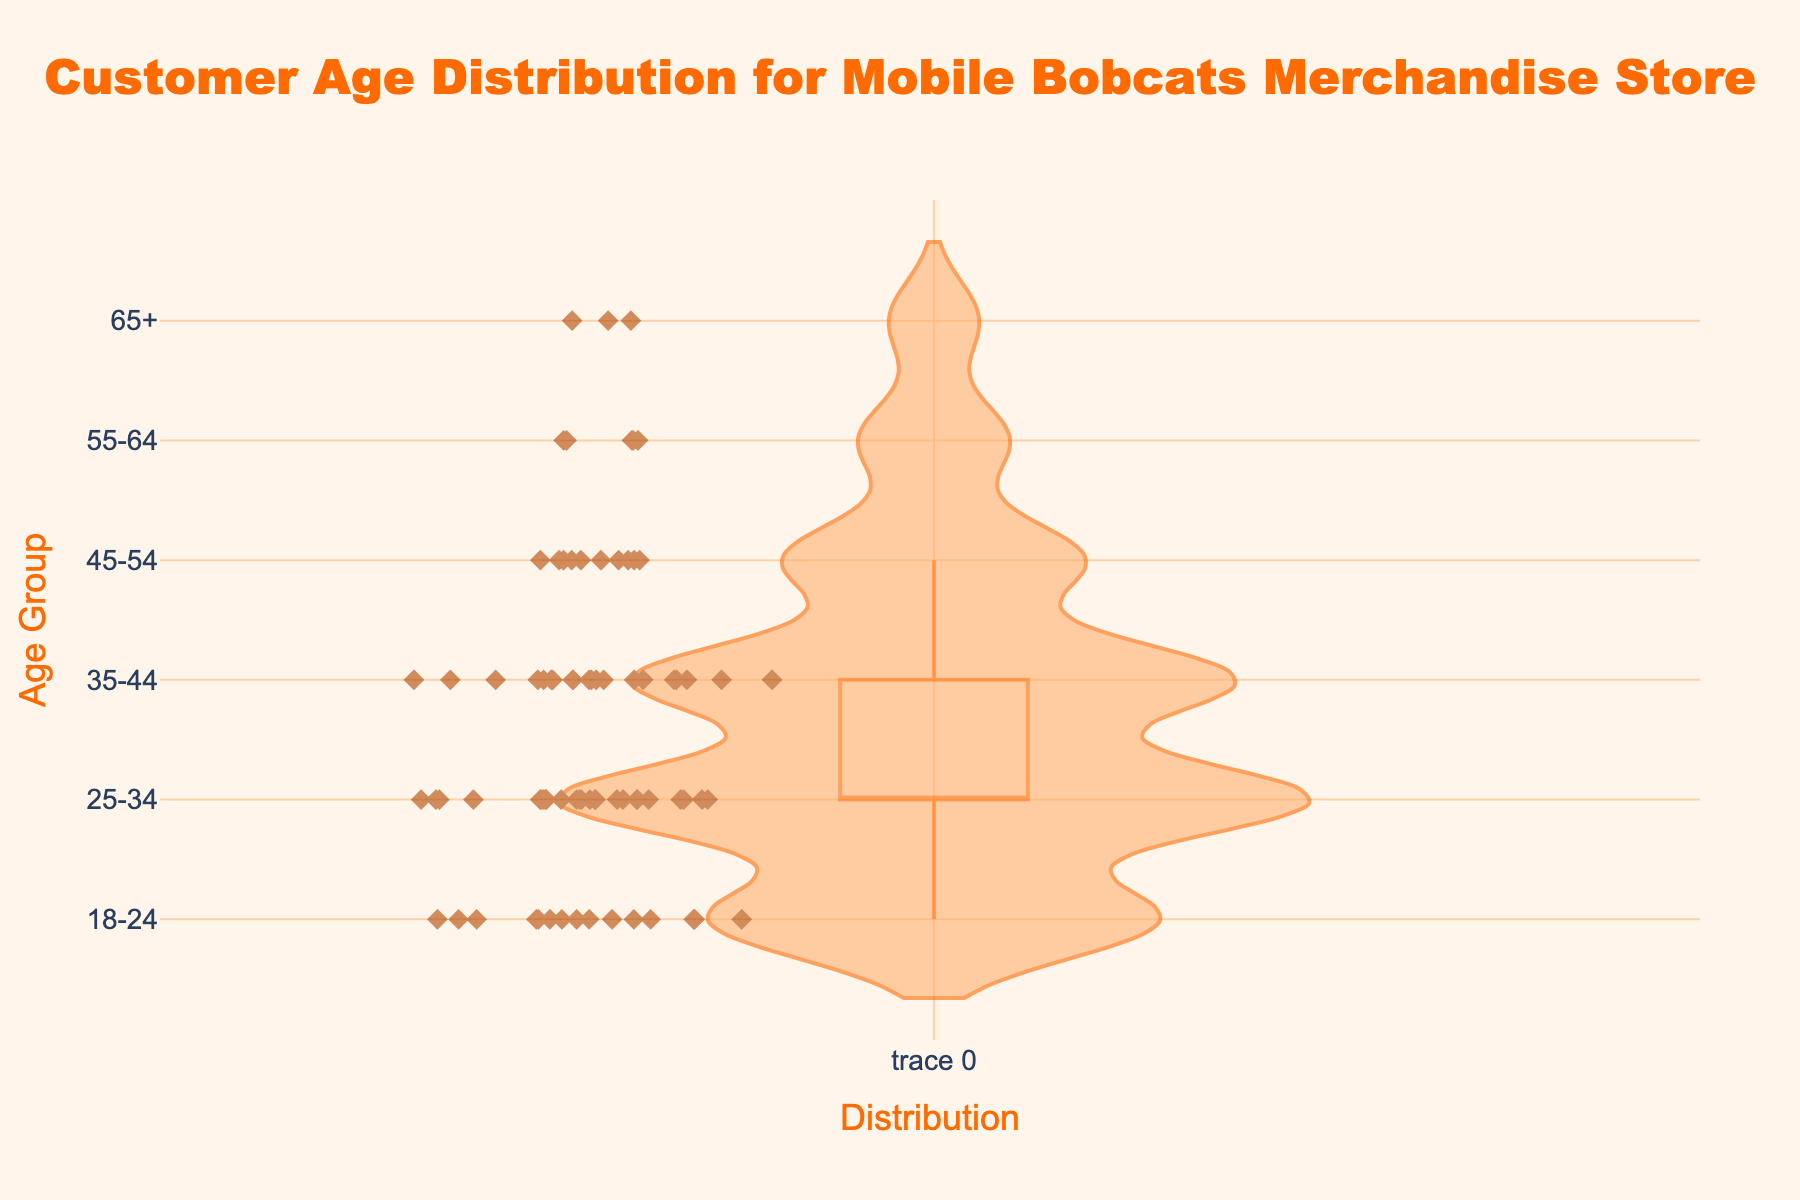What is the title of the figure? The title of the figure is often placed at the top and is typically larger and more prominent. In this figure, it is clearly stated: "Customer Age Distribution for Mobile Bobcats Merchandise Store".
Answer: Customer Age Distribution for Mobile Bobcats Merchandise Store What do the colors represent in the violin plot? In this violin plot, the colors are used for visual aesthetics and to distinguish various components. The fill color of the plot is an orange shade, which visually separates the density area. The markers (points) are brown and represent individual data points with a diamond shape to highlight them.
Answer: Different parts of the plot Which age group has the highest customer count? By looking at the distribution of points along the y-axis and their concentration, the age group '25-34' appears to have the most points. Checking the distribution confirms this visually.
Answer: 25-34 How many customer data points fall in the age group 55-64? The plot shows individual diamond markers for each data point. For '55-64', we see exactly five markers corresponding to the count.
Answer: 5 What is the visible range of age groups on the y-axis? The y-axis shows the divisions for each age group. From the plot, we see age groups starting from '18-24' to '65+'.
Answer: 18-24 to 65+ Which age group has the least number of customers? By counting the points in each age group and comparing them, the '65+' age group has the fewest points.
Answer: 65+ Compare the customer counts between the age groups 35-44 and 45-54. The number of points for '35-44' and '45-54' can be counted to compare them. '35-44' has 20 points, whereas '45-54' has only 10 points. Therefore, '35-44' has more customers.
Answer: 35-44 has more customers What is the total number of customer data points represented in the plot? Summing up the counts for all age groups: 15 (18-24) + 25 (25-34) + 20 (35-44) + 10 (45-54) + 5 (55-64) + 3 (65+). This sums up to 78.
Answer: 78 Describe the distribution shape in the violin plot for the age group 25-34. The violin plot's width at each point indicates density. '25-34' is the widest, suggesting a high concentration of customers in this range. This indicates a peak or high density in the distribution of customers.
Answer: High concentration 